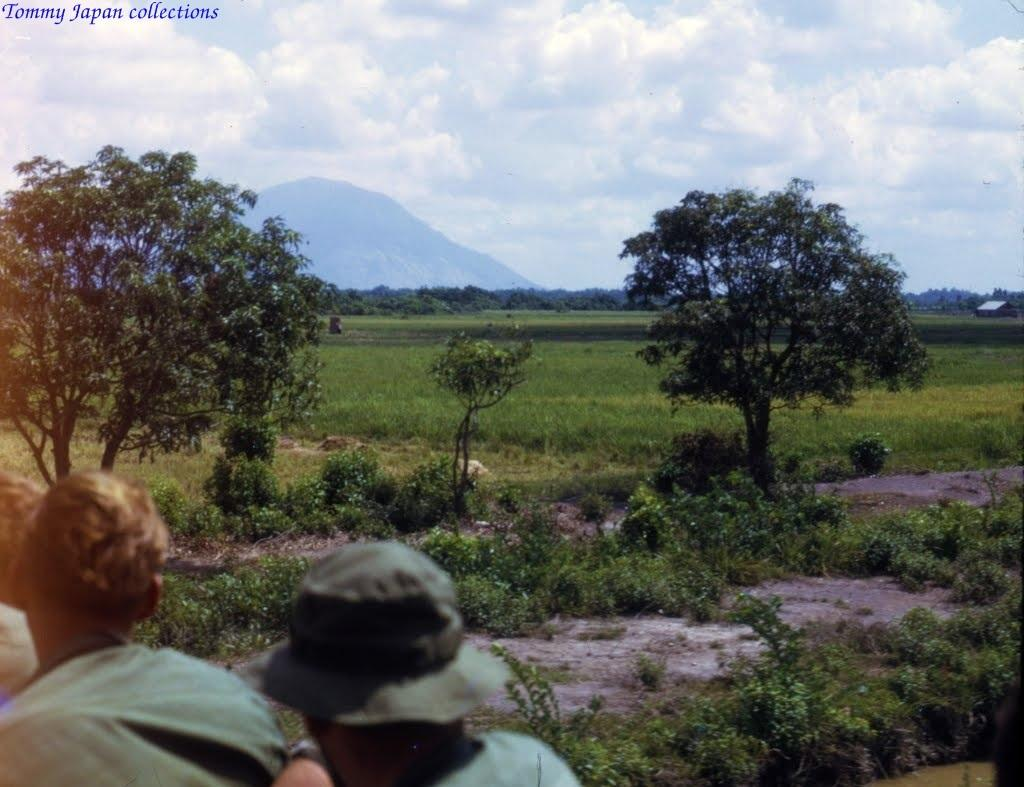What can be seen in the sky in the image? The sky with clouds is visible in the image. What type of landscape features are present in the image? There are hills, trees, grass, and shrubs in the image. What is the ground like in the image? The ground is visible in the image. Are there any people in the image? Yes, there are persons in the image. What type of rod is being used by the carpenter in the image? There is no carpenter or rod present in the image. 